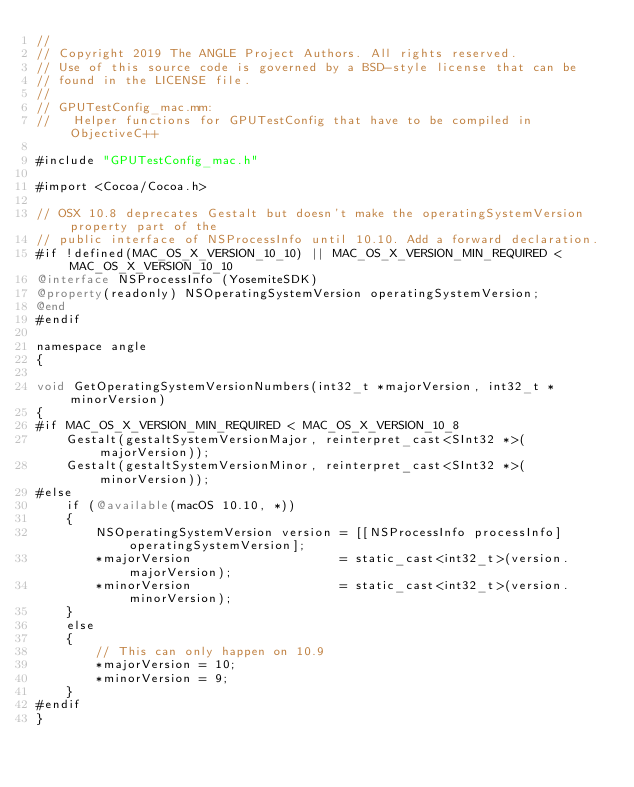<code> <loc_0><loc_0><loc_500><loc_500><_ObjectiveC_>//
// Copyright 2019 The ANGLE Project Authors. All rights reserved.
// Use of this source code is governed by a BSD-style license that can be
// found in the LICENSE file.
//
// GPUTestConfig_mac.mm:
//   Helper functions for GPUTestConfig that have to be compiled in ObjectiveC++

#include "GPUTestConfig_mac.h"

#import <Cocoa/Cocoa.h>

// OSX 10.8 deprecates Gestalt but doesn't make the operatingSystemVersion property part of the
// public interface of NSProcessInfo until 10.10. Add a forward declaration.
#if !defined(MAC_OS_X_VERSION_10_10) || MAC_OS_X_VERSION_MIN_REQUIRED < MAC_OS_X_VERSION_10_10
@interface NSProcessInfo (YosemiteSDK)
@property(readonly) NSOperatingSystemVersion operatingSystemVersion;
@end
#endif

namespace angle
{

void GetOperatingSystemVersionNumbers(int32_t *majorVersion, int32_t *minorVersion)
{
#if MAC_OS_X_VERSION_MIN_REQUIRED < MAC_OS_X_VERSION_10_8
    Gestalt(gestaltSystemVersionMajor, reinterpret_cast<SInt32 *>(majorVersion));
    Gestalt(gestaltSystemVersionMinor, reinterpret_cast<SInt32 *>(minorVersion));
#else
    if (@available(macOS 10.10, *))
    {
        NSOperatingSystemVersion version = [[NSProcessInfo processInfo] operatingSystemVersion];
        *majorVersion                    = static_cast<int32_t>(version.majorVersion);
        *minorVersion                    = static_cast<int32_t>(version.minorVersion);
    }
    else
    {
        // This can only happen on 10.9
        *majorVersion = 10;
        *minorVersion = 9;
    }
#endif
}
</code> 